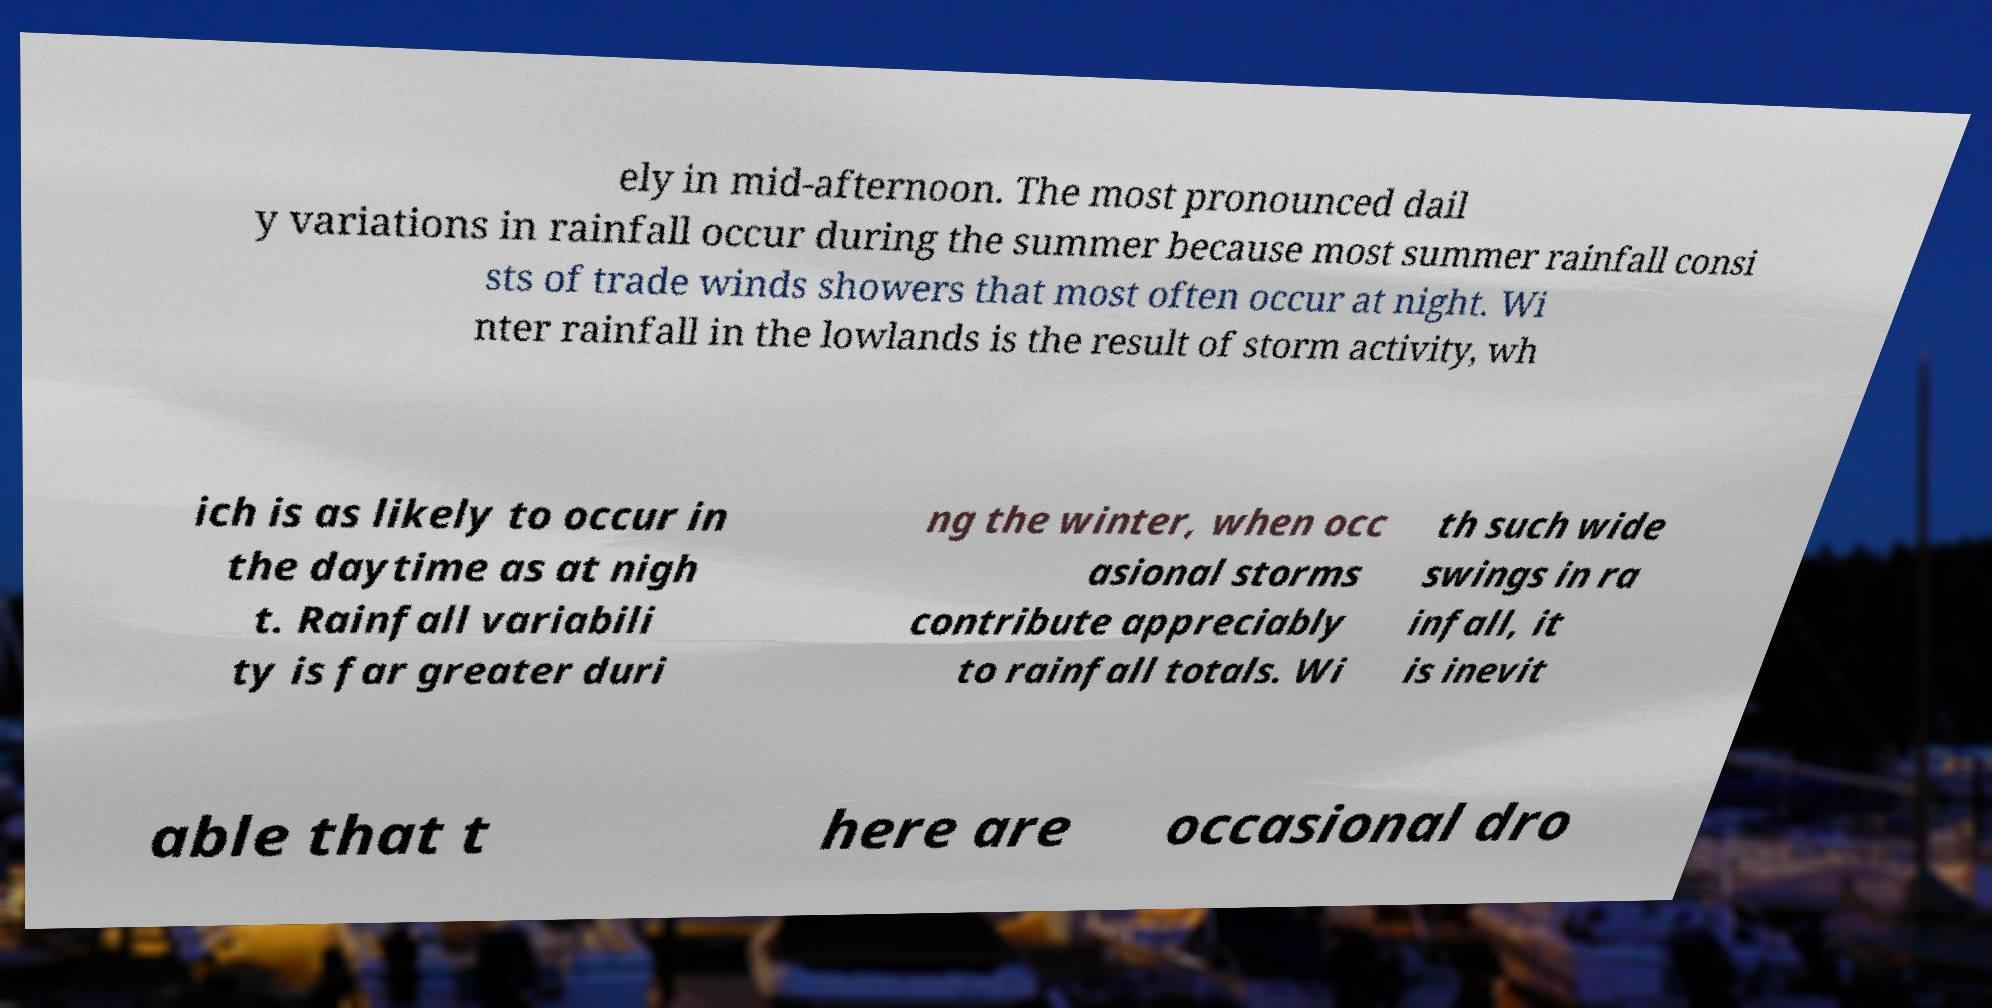Can you accurately transcribe the text from the provided image for me? ely in mid-afternoon. The most pronounced dail y variations in rainfall occur during the summer because most summer rainfall consi sts of trade winds showers that most often occur at night. Wi nter rainfall in the lowlands is the result of storm activity, wh ich is as likely to occur in the daytime as at nigh t. Rainfall variabili ty is far greater duri ng the winter, when occ asional storms contribute appreciably to rainfall totals. Wi th such wide swings in ra infall, it is inevit able that t here are occasional dro 